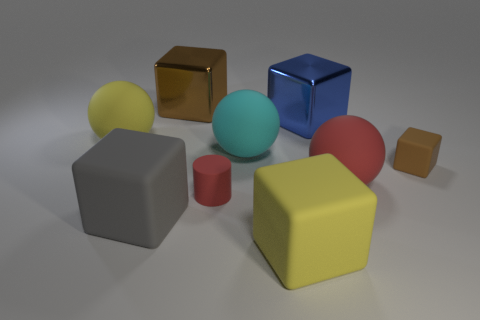What shape is the gray object that is the same size as the yellow cube?
Your response must be concise. Cube. Do the cylinder and the large sphere that is on the right side of the large yellow matte block have the same color?
Keep it short and to the point. Yes. How many things are brown cubes on the left side of the tiny red rubber thing or large rubber objects that are in front of the yellow matte ball?
Your response must be concise. 5. There is a red thing that is the same size as the brown shiny cube; what material is it?
Make the answer very short. Rubber. How many other objects are the same material as the small block?
Keep it short and to the point. 6. There is a large yellow object that is on the left side of the big gray matte cube; is it the same shape as the yellow rubber thing that is in front of the small rubber cylinder?
Provide a short and direct response. No. What color is the big metallic thing that is right of the big brown block that is to the left of the rubber ball that is in front of the small brown rubber object?
Provide a succinct answer. Blue. Are there fewer yellow cubes than tiny metal cylinders?
Provide a succinct answer. No. There is a rubber block that is to the right of the cyan thing and to the left of the small matte cube; what is its color?
Keep it short and to the point. Yellow. There is a blue thing that is the same shape as the brown matte object; what is it made of?
Make the answer very short. Metal. 